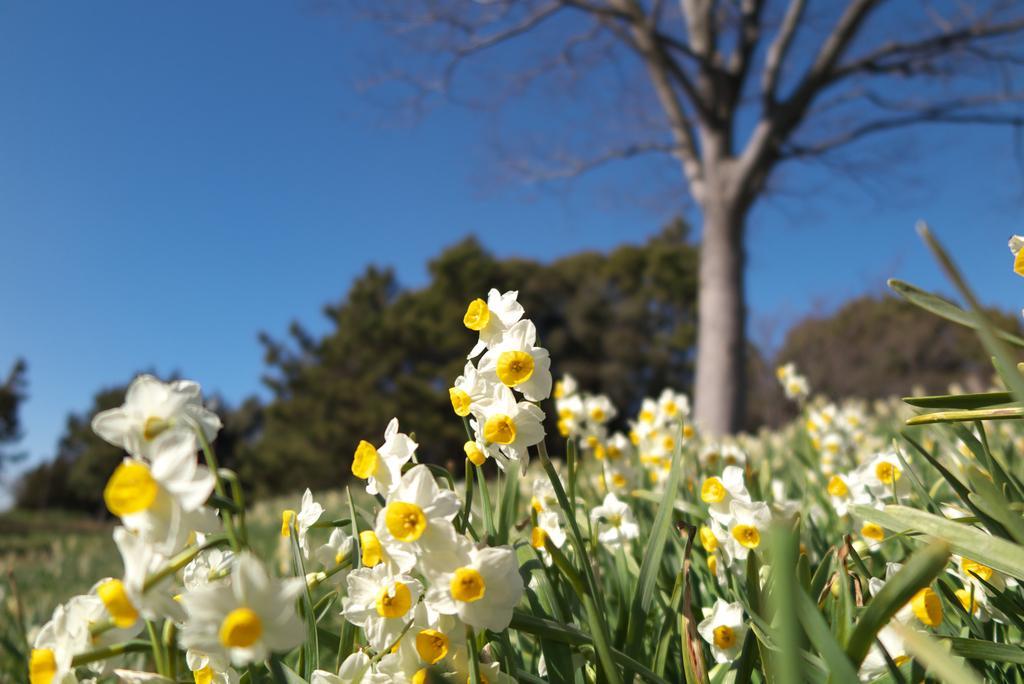Please provide a concise description of this image. In this image there are so many flower plants beside that there are so many trees. 